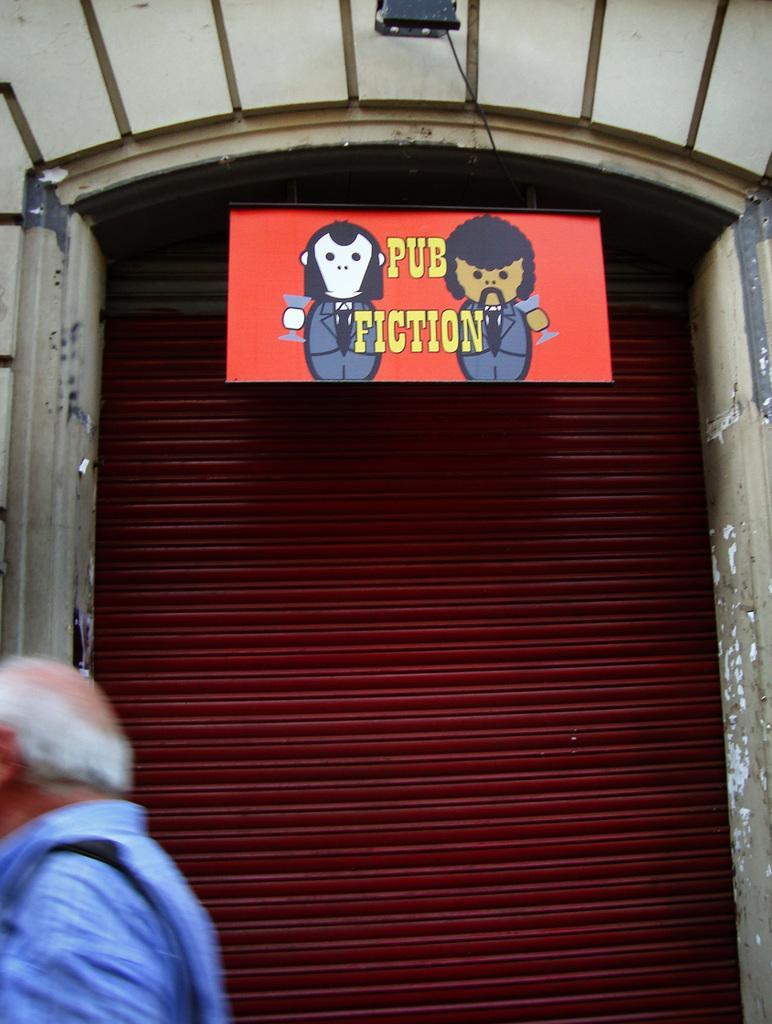Please provide a concise description of this image. A person is present at the left wearing a blue shirt. There is a shutter at the back and a board is hanging above it. 